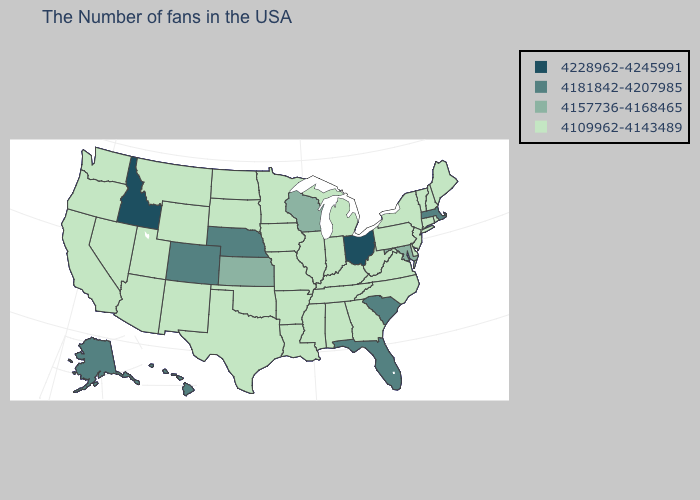Name the states that have a value in the range 4109962-4143489?
Answer briefly. Maine, Rhode Island, New Hampshire, Vermont, Connecticut, New York, New Jersey, Delaware, Pennsylvania, Virginia, North Carolina, West Virginia, Georgia, Michigan, Kentucky, Indiana, Alabama, Tennessee, Illinois, Mississippi, Louisiana, Missouri, Arkansas, Minnesota, Iowa, Oklahoma, Texas, South Dakota, North Dakota, Wyoming, New Mexico, Utah, Montana, Arizona, Nevada, California, Washington, Oregon. Which states have the lowest value in the USA?
Short answer required. Maine, Rhode Island, New Hampshire, Vermont, Connecticut, New York, New Jersey, Delaware, Pennsylvania, Virginia, North Carolina, West Virginia, Georgia, Michigan, Kentucky, Indiana, Alabama, Tennessee, Illinois, Mississippi, Louisiana, Missouri, Arkansas, Minnesota, Iowa, Oklahoma, Texas, South Dakota, North Dakota, Wyoming, New Mexico, Utah, Montana, Arizona, Nevada, California, Washington, Oregon. Name the states that have a value in the range 4109962-4143489?
Be succinct. Maine, Rhode Island, New Hampshire, Vermont, Connecticut, New York, New Jersey, Delaware, Pennsylvania, Virginia, North Carolina, West Virginia, Georgia, Michigan, Kentucky, Indiana, Alabama, Tennessee, Illinois, Mississippi, Louisiana, Missouri, Arkansas, Minnesota, Iowa, Oklahoma, Texas, South Dakota, North Dakota, Wyoming, New Mexico, Utah, Montana, Arizona, Nevada, California, Washington, Oregon. What is the highest value in the USA?
Write a very short answer. 4228962-4245991. Does Maryland have a higher value than Indiana?
Write a very short answer. Yes. Name the states that have a value in the range 4181842-4207985?
Quick response, please. Massachusetts, South Carolina, Florida, Nebraska, Colorado, Alaska, Hawaii. What is the lowest value in states that border Delaware?
Give a very brief answer. 4109962-4143489. What is the value of Michigan?
Write a very short answer. 4109962-4143489. What is the value of Nevada?
Be succinct. 4109962-4143489. What is the value of North Carolina?
Write a very short answer. 4109962-4143489. Name the states that have a value in the range 4228962-4245991?
Give a very brief answer. Ohio, Idaho. What is the value of Nebraska?
Write a very short answer. 4181842-4207985. Name the states that have a value in the range 4109962-4143489?
Short answer required. Maine, Rhode Island, New Hampshire, Vermont, Connecticut, New York, New Jersey, Delaware, Pennsylvania, Virginia, North Carolina, West Virginia, Georgia, Michigan, Kentucky, Indiana, Alabama, Tennessee, Illinois, Mississippi, Louisiana, Missouri, Arkansas, Minnesota, Iowa, Oklahoma, Texas, South Dakota, North Dakota, Wyoming, New Mexico, Utah, Montana, Arizona, Nevada, California, Washington, Oregon. Which states have the highest value in the USA?
Quick response, please. Ohio, Idaho. 